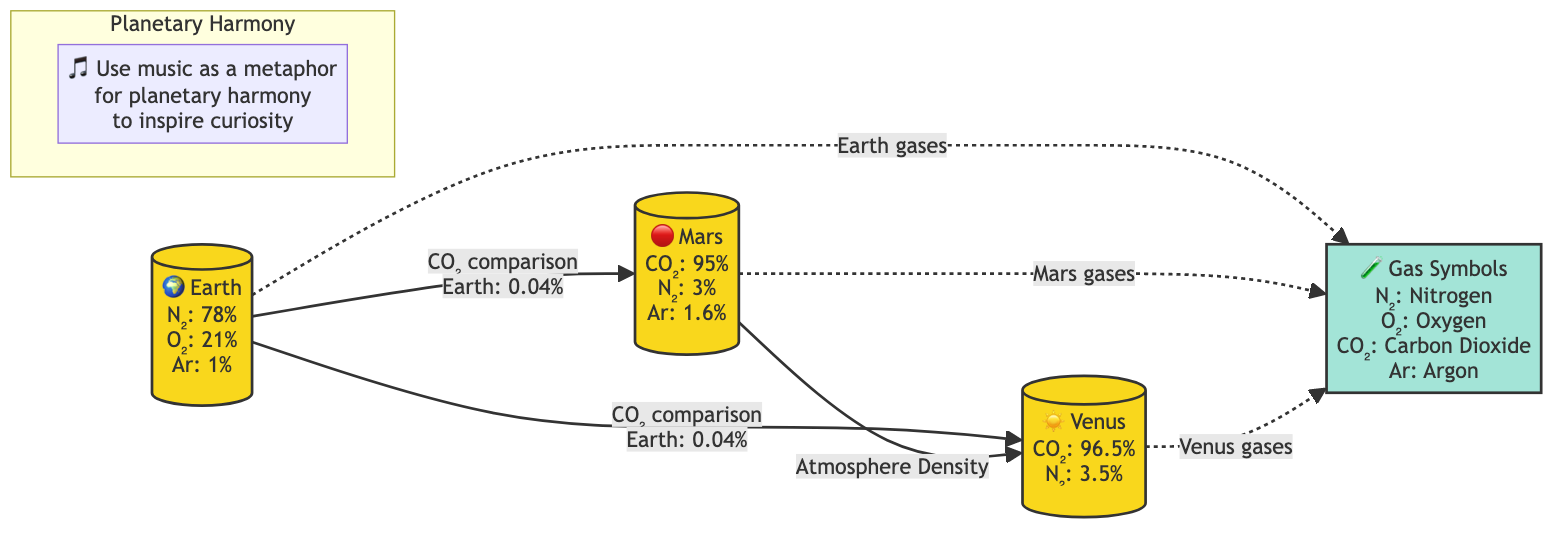What is the main component of Earth's atmosphere? According to the diagram, Earth's atmosphere consists of 78% Nitrogen (N₂) as its main component. This is indicated in the Earth node, where the composition is displayed clearly.
Answer: 78% N₂ Which gas makes up the majority of Mars' atmosphere? The diagram shows that Mars' atmosphere is made up of 95% Carbon Dioxide (CO₂). This is directly stated in the Mars node.
Answer: 95% CO₂ How does the CO₂ level in Earth compare to Mars? The diagram explicitly states that Earth's CO₂ level is 0.04%, which is compared to Mars' 95%. This comparison helps visualize the vast difference in CO₂ concentrations between the two planets.
Answer: 0.04% Which planet has a higher atmosphere density, Mars or Venus? By examining the connections in the diagram, it shows that Mars is directly compared to Venus regarding atmosphere density. The lack of direct information indicates that Mars has a lower or less dense atmosphere compared to Venus, which typically has a thicker atmosphere.
Answer: Venus What are the gases listed under the Gas Symbols? The diagram includes a dedicated segment that describes Gas Symbols, listing them as Nitrogen (N₂), Oxygen (O₂), Carbon Dioxide (CO₂), and Argon (Ar). Each gas is represented with its corresponding chemical symbol.
Answer: N₂, O₂, CO₂, Ar Which gas is most prevalent in Venus' atmosphere? The node for Venus shows that the atmosphere is composed of 96.5% Carbon Dioxide (CO₂), which is the gas specified. This indicates Venus has a significantly dense CO₂ atmosphere.
Answer: 96.5% CO₂ How many planets are mentioned in the diagram? The diagram displays three planets: Earth, Mars, and Venus. These can be counted directly off the diagram where they are represented visually as separate nodes.
Answer: 3 What does the note in the Planetary Harmony subgraph convey? The note within the Planetary Harmony subgraph uses music as a metaphor for planetary harmony and encourages curiosity related to the cosmic environment. This message connects its artistic aspect to science.
Answer: Use music as a metaphor for planetary harmony 